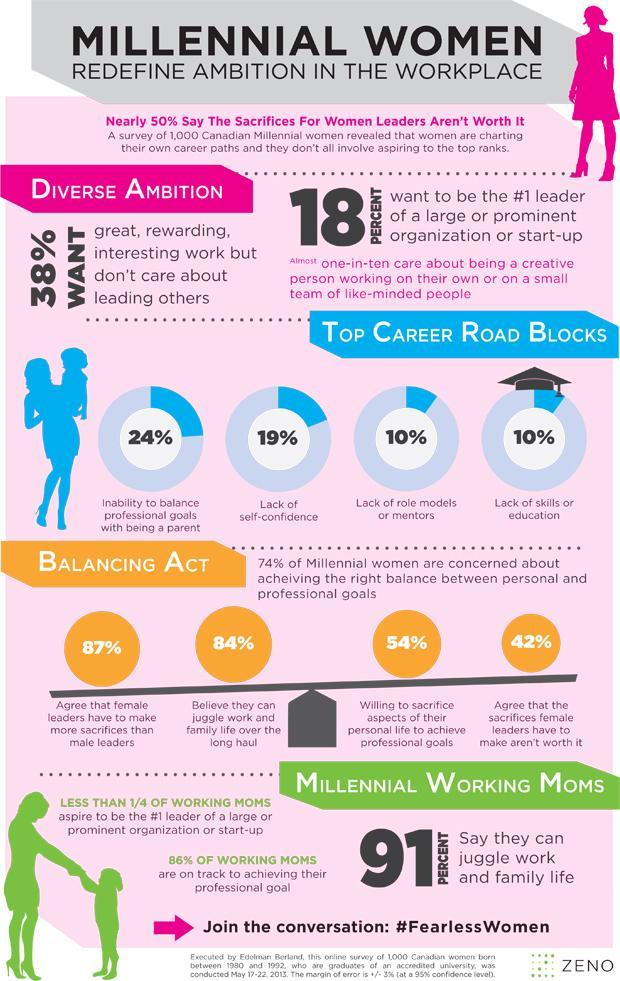What percentage of career roadblocks for women is not the inability to balance professional goals with being a parent?
Answer the question with a short phrase. 76% What percentage are not willing to sacrifice aspects of their personal life to achieve professional goals? 46% What percentage of career roadblocks for women is not lack of skills or education? 90% What percentage of career roadblocks for women is not lack of confidence? 81% What percentage of career roadblocks for women is not a lack of role models or mentors? 90% What percentage of women don't want to be the #1 leader of a large or prominent organization or start-up? 82% What percentage of millennial women are not concerned about achieving the right balance between personal and professional goals? 26% 